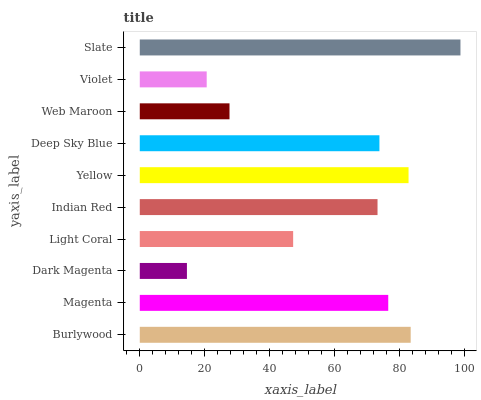Is Dark Magenta the minimum?
Answer yes or no. Yes. Is Slate the maximum?
Answer yes or no. Yes. Is Magenta the minimum?
Answer yes or no. No. Is Magenta the maximum?
Answer yes or no. No. Is Burlywood greater than Magenta?
Answer yes or no. Yes. Is Magenta less than Burlywood?
Answer yes or no. Yes. Is Magenta greater than Burlywood?
Answer yes or no. No. Is Burlywood less than Magenta?
Answer yes or no. No. Is Deep Sky Blue the high median?
Answer yes or no. Yes. Is Indian Red the low median?
Answer yes or no. Yes. Is Magenta the high median?
Answer yes or no. No. Is Slate the low median?
Answer yes or no. No. 